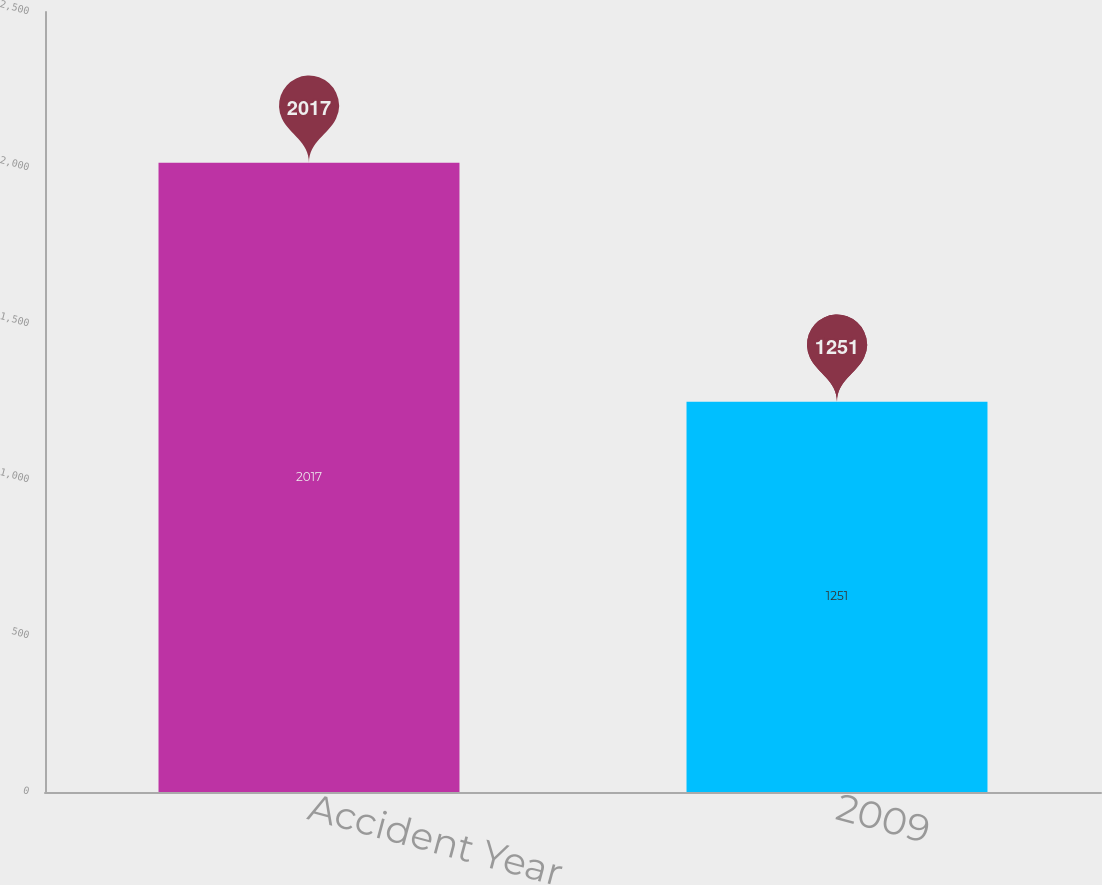Convert chart. <chart><loc_0><loc_0><loc_500><loc_500><bar_chart><fcel>Accident Year<fcel>2009<nl><fcel>2017<fcel>1251<nl></chart> 